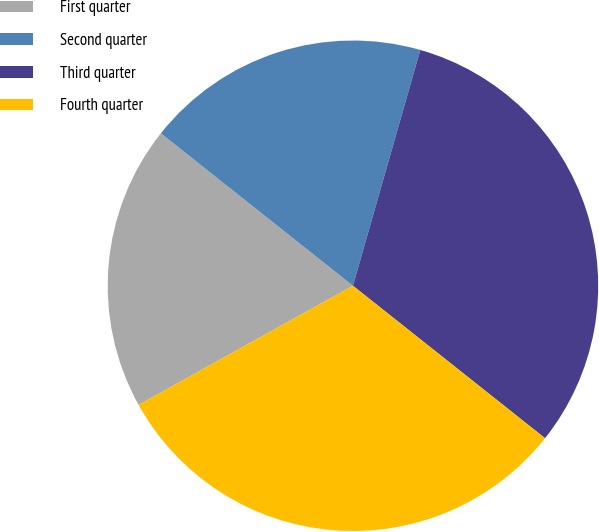Convert chart. <chart><loc_0><loc_0><loc_500><loc_500><pie_chart><fcel>First quarter<fcel>Second quarter<fcel>Third quarter<fcel>Fourth quarter<nl><fcel>18.75%<fcel>18.75%<fcel>31.25%<fcel>31.25%<nl></chart> 